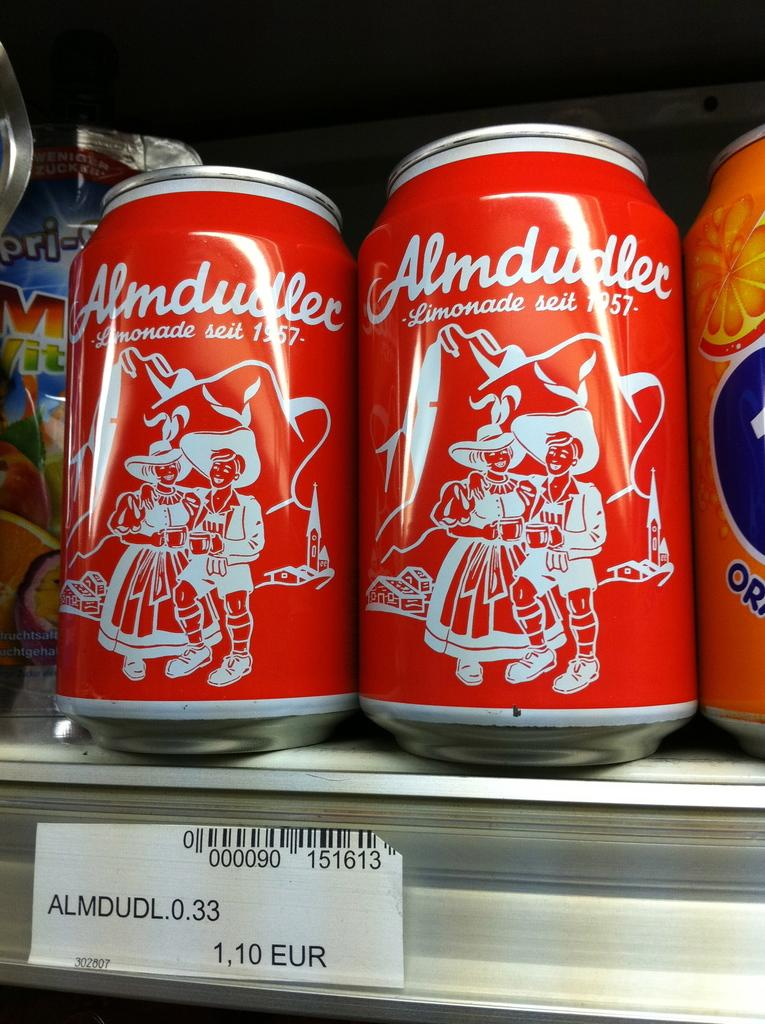<image>
Describe the image concisely. Two cans of Almdudler are sitting between fruit drinks on a store shelf. 